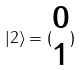Convert formula to latex. <formula><loc_0><loc_0><loc_500><loc_500>| 2 \rangle = ( \begin{matrix} 0 \\ 1 \end{matrix} )</formula> 